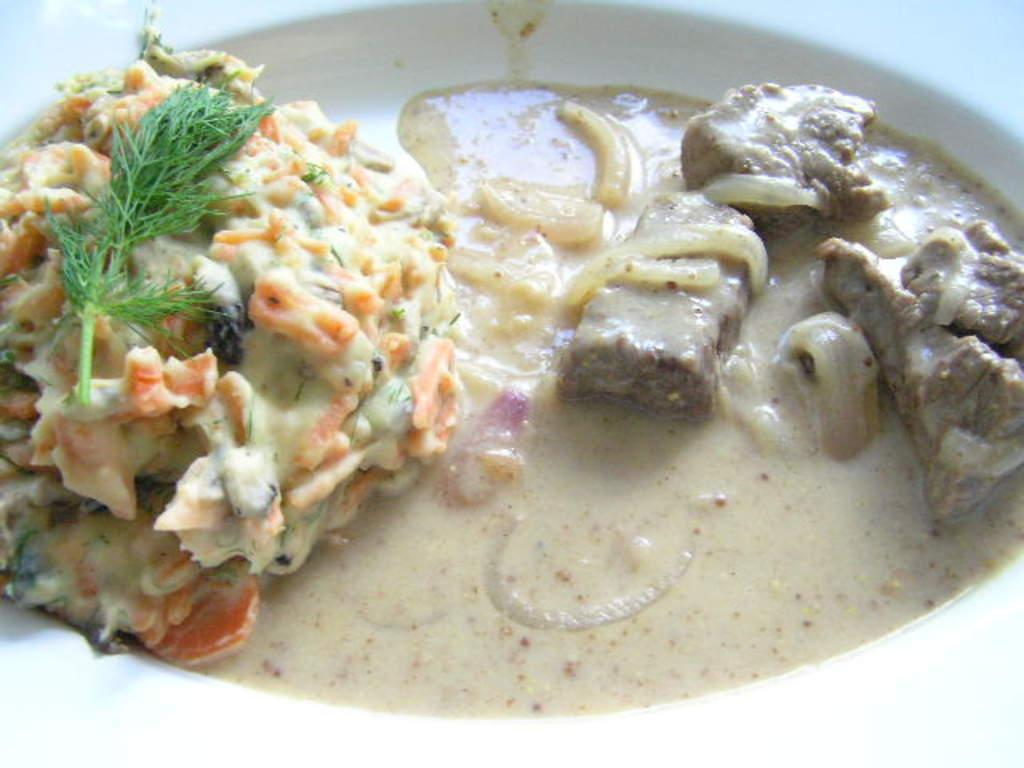What object is present in the image that typically holds food? There is a plate in the image. What is on the plate? The plate contains food. What type of protest is taking place in the image? There is no protest present in the image; it only contains a plate with food. What kind of wilderness can be seen in the image? There is no wilderness present in the image; it only contains a plate with food. 